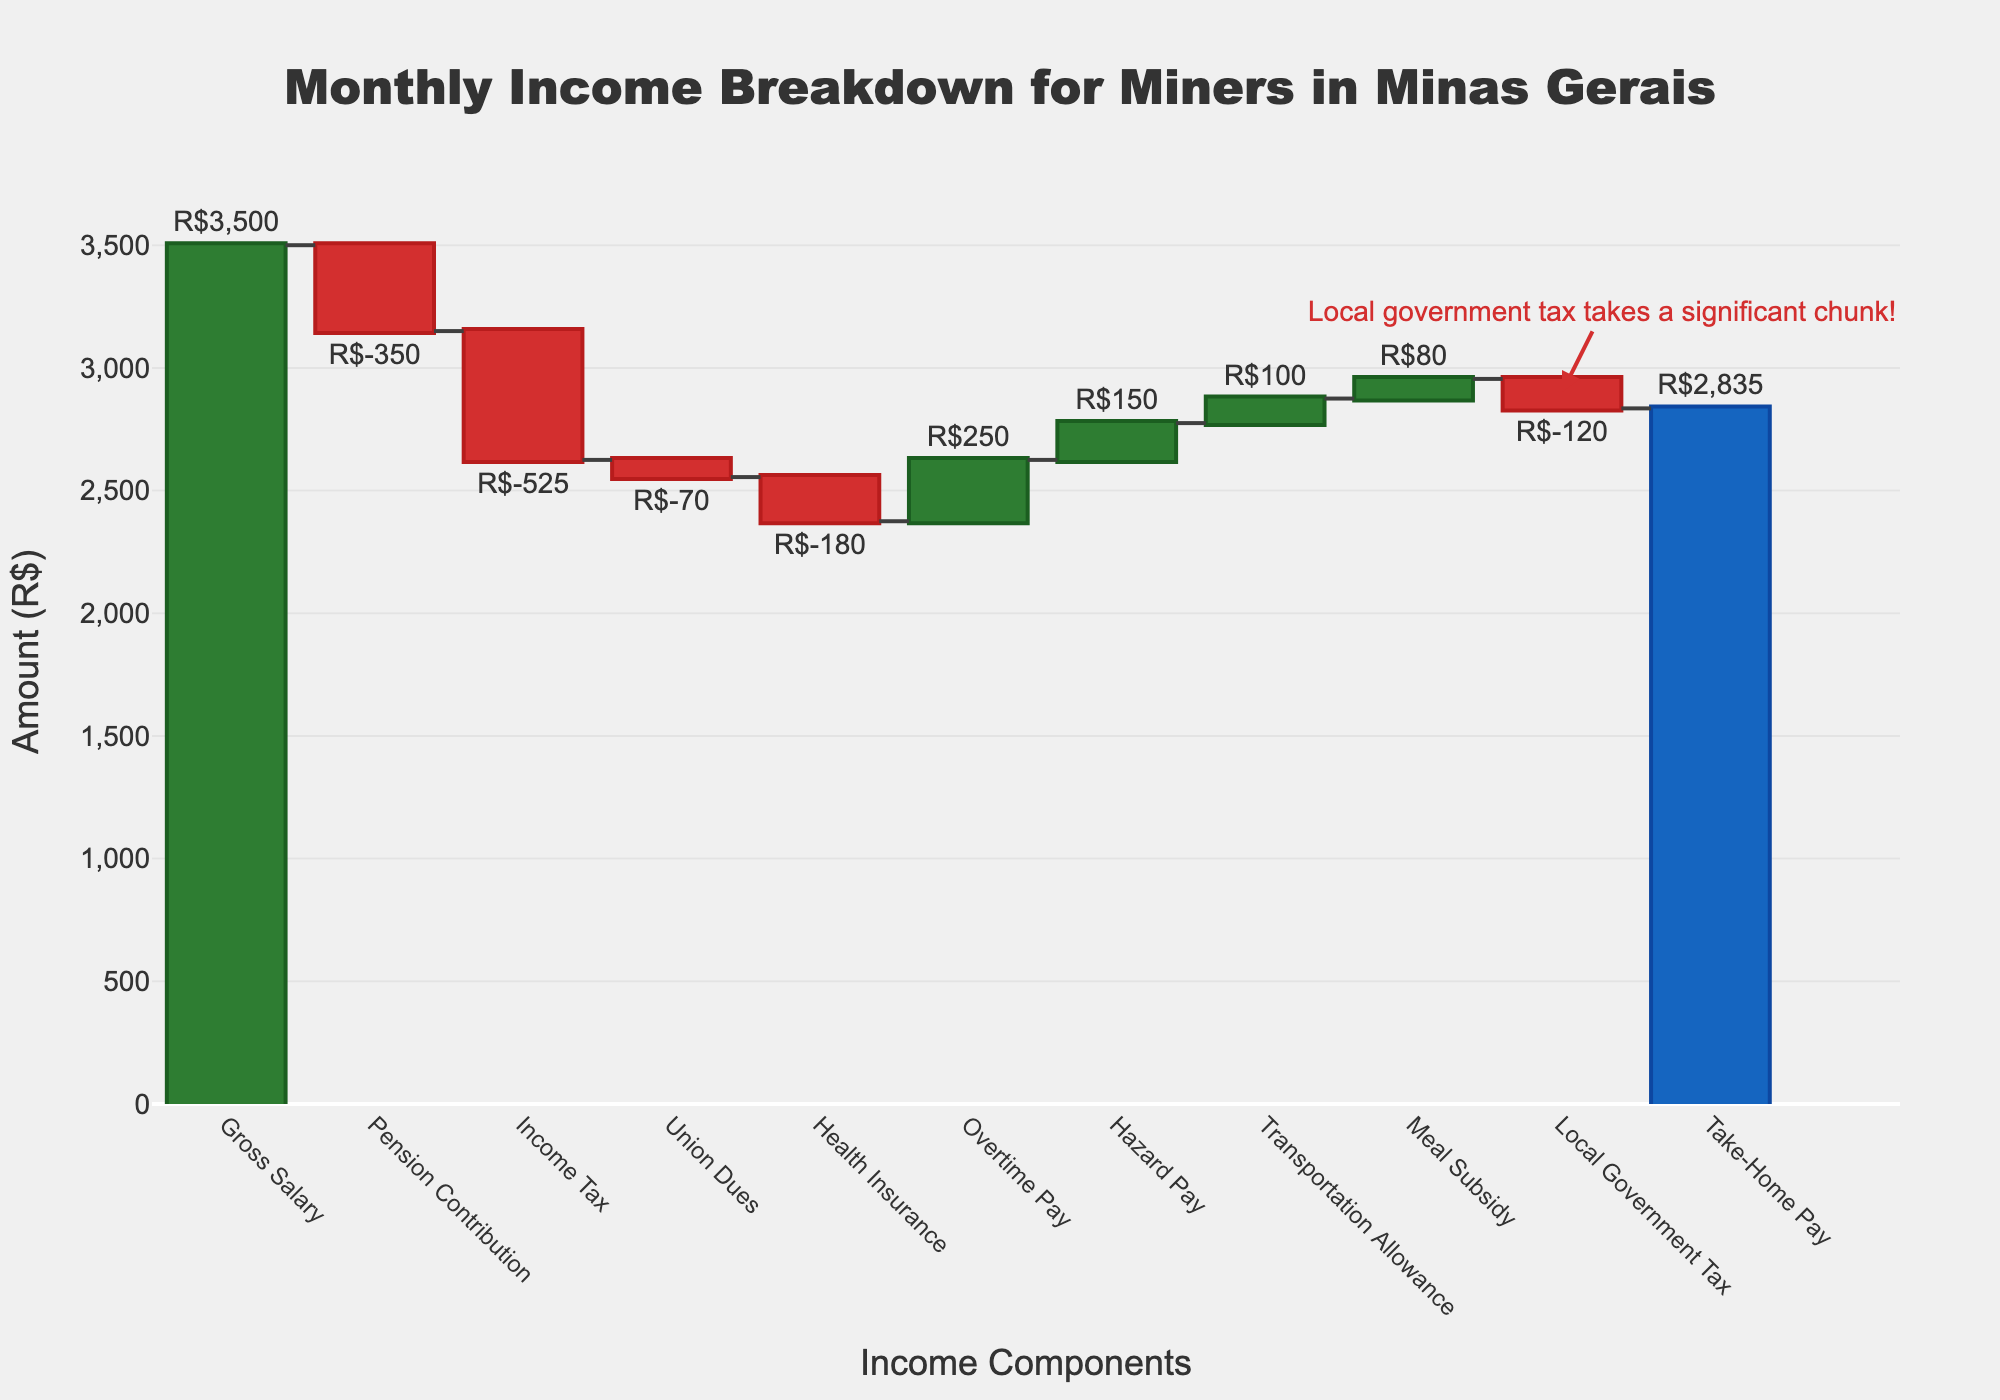What is the title of the chart? The title of the chart is displayed prominently at the top of the figure. It reads "Monthly Income Breakdown for Miners in Minas Gerais."
Answer: Monthly Income Breakdown for Miners in Minas Gerais What is the gross salary of the miners? The gross salary is labeled at the very beginning (first bar) of the waterfall chart and is marked with an amount of R$3,500.
Answer: R$3,500 How much is deducted for income tax? The bar labeled "Income Tax" shows the amount deducted. The corresponding value is -R$525.
Answer: -R$525 Which component provides the highest addition to the income? By comparing the heights of the positive bars, "Overtime Pay" adds the most to the income with a value of R$250.
Answer: Overtime Pay Which deduction has the smallest impact on take-home pay? The bar labeled "Union Dues" has the smallest deduction with a value of -R$70.
Answer: Union Dues What is the final take-home pay? The take-home pay is indicated as the last total bar in the waterfall chart, showing R$2,835.
Answer: R$2,835 Calculate the total amount deducted excluding the local government tax. Sum the deductions: Pension (-R$350) + Income Tax (-R$525) + Union Dues (-R$70) + Health Insurance (-R$180) = -R$1,125
Answer: -R$1,125 What is the combined contribution from hazard pay, transportation allowance, and meal subsidy? Sum the positive contributions: Hazard Pay (R$150) + Transportation Allowance (R$100) + Meal Subsidy (R$80) = R$330
Answer: R$330 Which has a greater deduction: health insurance or local government tax? Compare the heights of the bars labeled "Health Insurance" and "Local Government Tax." Health insurance has a deduction of -R$180, which is greater than the local government tax of -R$120.
Answer: Health Insurance Is the annotation accurate about the impact of the local government tax? The annotation points out that the local government tax takes a significant chunk; the bar shows a deduction of -R$120, which is substantial but smaller compared to other deductions like income tax.
Answer: The annotation is somewhat accurate 